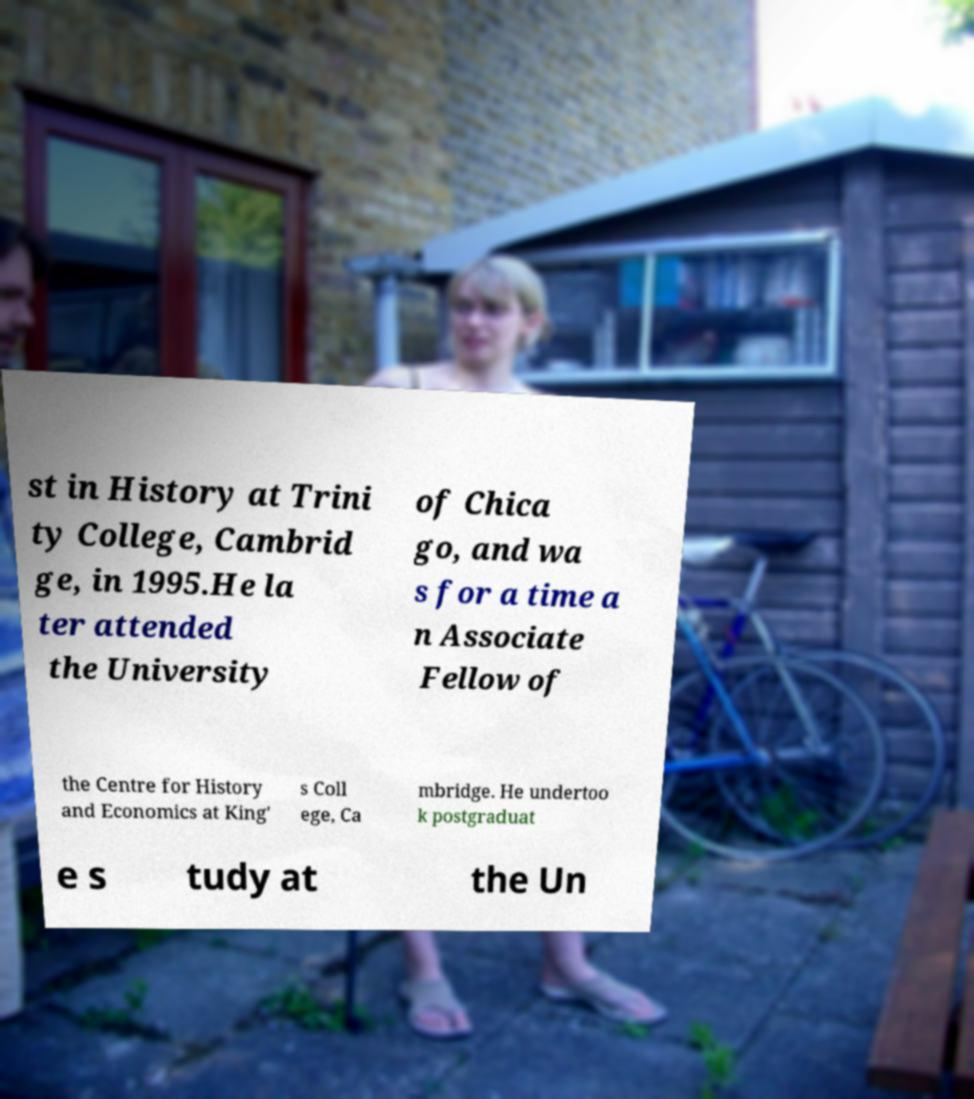I need the written content from this picture converted into text. Can you do that? st in History at Trini ty College, Cambrid ge, in 1995.He la ter attended the University of Chica go, and wa s for a time a n Associate Fellow of the Centre for History and Economics at King' s Coll ege, Ca mbridge. He undertoo k postgraduat e s tudy at the Un 